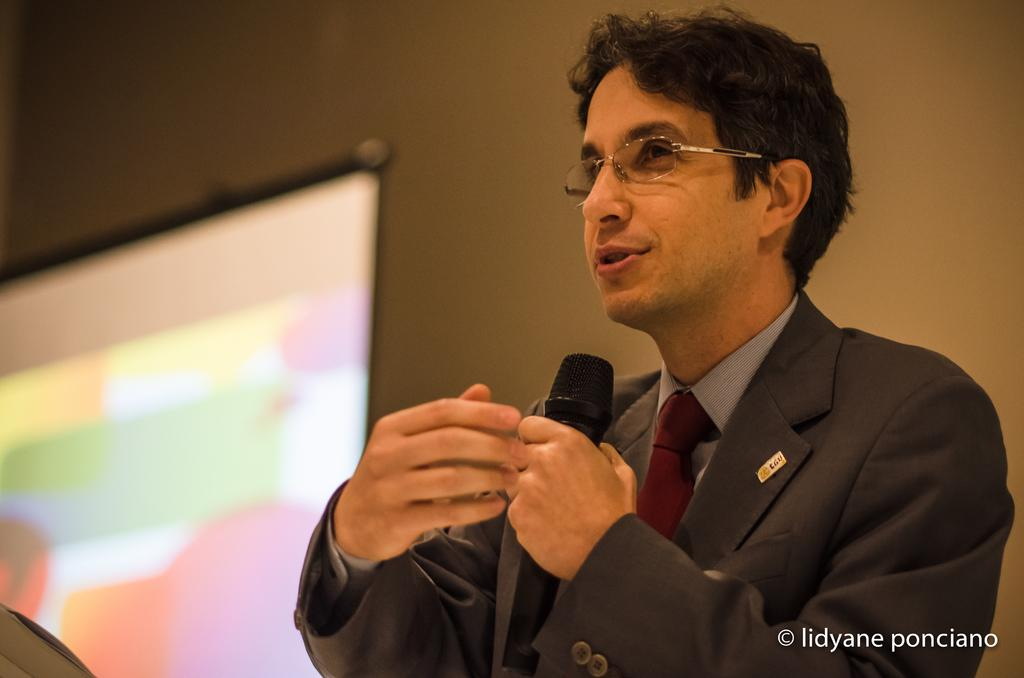What is the man doing in the image? The man is standing on the right side of the image and holding a mic in his hand. What can be seen on the left side of the image? There is a screen on the left side of the image. What is visible in the background of the image? There is a wall in the background of the image. What type of statement can be seen on the branch in the image? There is no branch present in the image, and therefore no statement can be seen on it. 